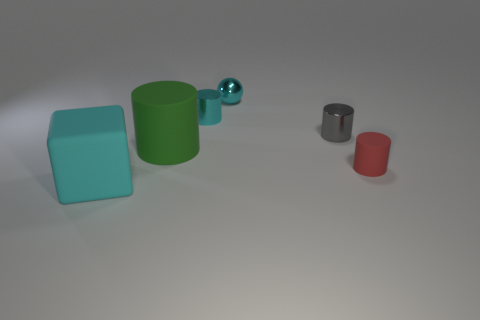There is a tiny thing that is both in front of the shiny ball and on the left side of the small gray cylinder; what is its material?
Ensure brevity in your answer.  Metal. What number of other metallic objects are the same shape as the green object?
Keep it short and to the point. 2. There is a rubber cylinder that is to the left of the gray metallic thing that is behind the big object behind the large cyan rubber block; what size is it?
Offer a very short reply. Large. Is the number of balls that are behind the cyan cylinder greater than the number of red matte balls?
Offer a very short reply. Yes. Are any objects visible?
Ensure brevity in your answer.  Yes. What number of green metallic things have the same size as the red cylinder?
Provide a short and direct response. 0. Is the number of cyan objects in front of the tiny red rubber cylinder greater than the number of cyan rubber things that are behind the gray metal cylinder?
Provide a succinct answer. Yes. There is a thing that is the same size as the cyan matte cube; what is its material?
Offer a terse response. Rubber. What shape is the red thing?
Make the answer very short. Cylinder. What number of blue things are large cylinders or rubber cylinders?
Your response must be concise. 0. 